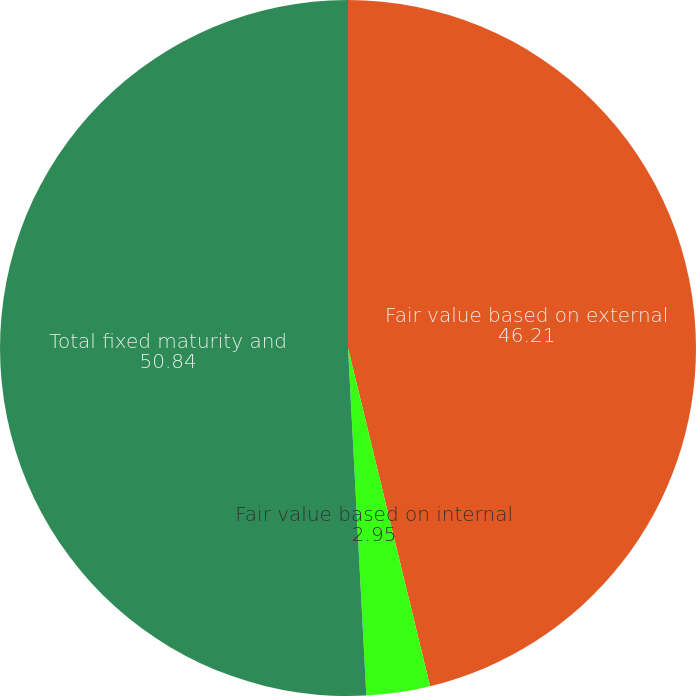Convert chart to OTSL. <chart><loc_0><loc_0><loc_500><loc_500><pie_chart><fcel>Fair value based on external<fcel>Fair value based on internal<fcel>Total fixed maturity and<nl><fcel>46.21%<fcel>2.95%<fcel>50.84%<nl></chart> 